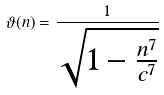Convert formula to latex. <formula><loc_0><loc_0><loc_500><loc_500>\vartheta ( n ) = \frac { 1 } { \sqrt { 1 - \frac { n ^ { 7 } } { c ^ { 7 } } } }</formula> 